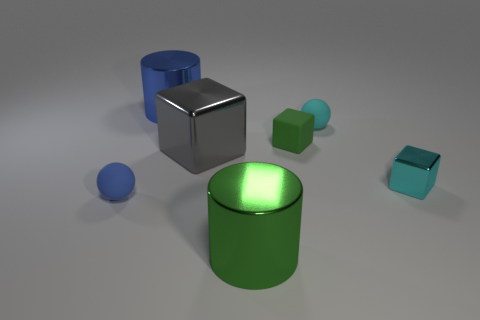Can you explain the lighting in this image? The lighting in the image seems to be diffuse, likely from a source not directly visible in the scene, providing soft shadows that give a calm and even tone to the composition.  How does the lighting affect the appearance of the materials? The diffuse lighting enhances the material properties, highlighting the subtle textures and reflectivity of the objects, particularly evident with the sheen on the metallic surfaces and the soft glow on the plastic finishes. 